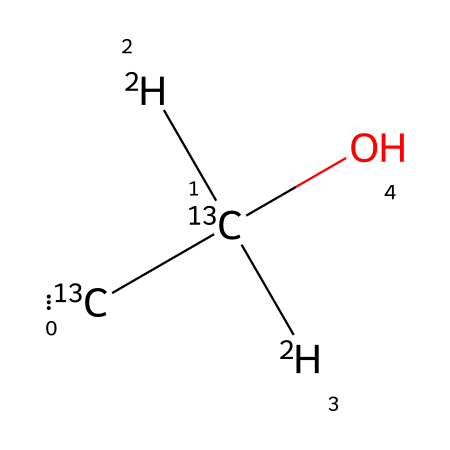What is the molecular formula for the ethanol depicted in the structure? The chemical structure shows two carbon atoms, six hydrogen atoms, and one oxygen atom, which leads to the molecular formula C2H6O.
Answer: C2H6O How many isotopes are represented in the SMILES notation? The notation includes two carbon isotopes (13C) and four hydrogen isotopes (2H), totaling six isotopes represented.
Answer: six What is the significance of the [13C] notation in this structure? The [13C] notation indicates the presence of carbon-13 isotopes, which are stable and used in various analytical techniques, particularly in isotope ratio mass spectrometry.
Answer: carbon-13 Which part of the molecule indicates its alcohol classification? The -OH (hydroxyl) group in the structure signifies that this molecule is an alcohol.
Answer: -OH group How do the deuterium atoms [2H] affect the properties of this ethanol? The presence of deuterium (2H) alters the molecular weight and can affect the reaction rates and physical properties, such as boiling point, due to the isotopic substitution effect.
Answer: reaction rates Which isotopes are commonly found in ethanol molecules? Ethanol commonly contains carbon-12, carbon-13, and hydrogen-1, along with heavy isotopes like deuterium (2H).
Answer: carbon-12, carbon-13, hydrogen-1, deuterium 